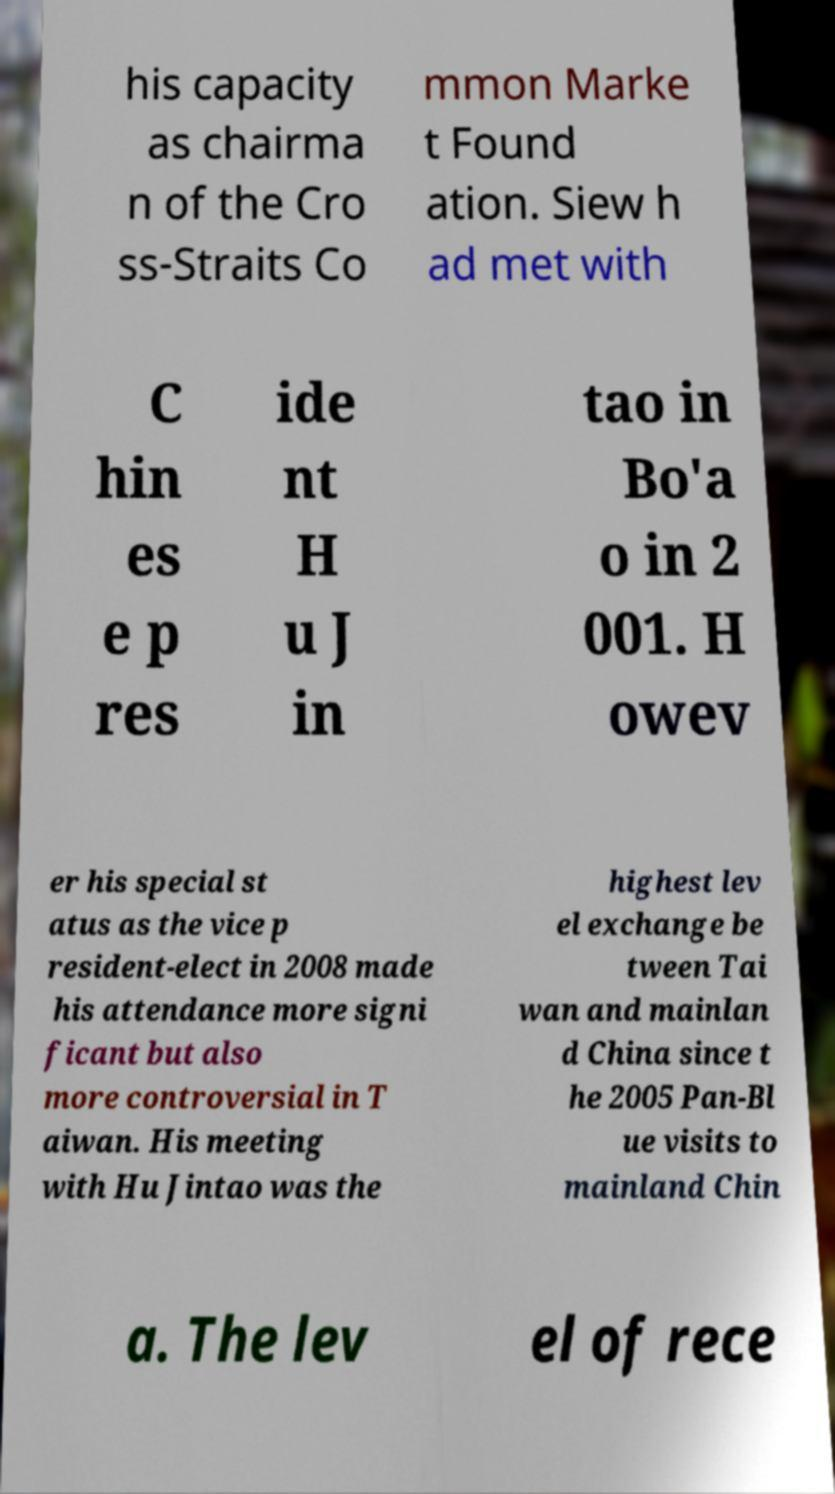What messages or text are displayed in this image? I need them in a readable, typed format. his capacity as chairma n of the Cro ss-Straits Co mmon Marke t Found ation. Siew h ad met with C hin es e p res ide nt H u J in tao in Bo'a o in 2 001. H owev er his special st atus as the vice p resident-elect in 2008 made his attendance more signi ficant but also more controversial in T aiwan. His meeting with Hu Jintao was the highest lev el exchange be tween Tai wan and mainlan d China since t he 2005 Pan-Bl ue visits to mainland Chin a. The lev el of rece 